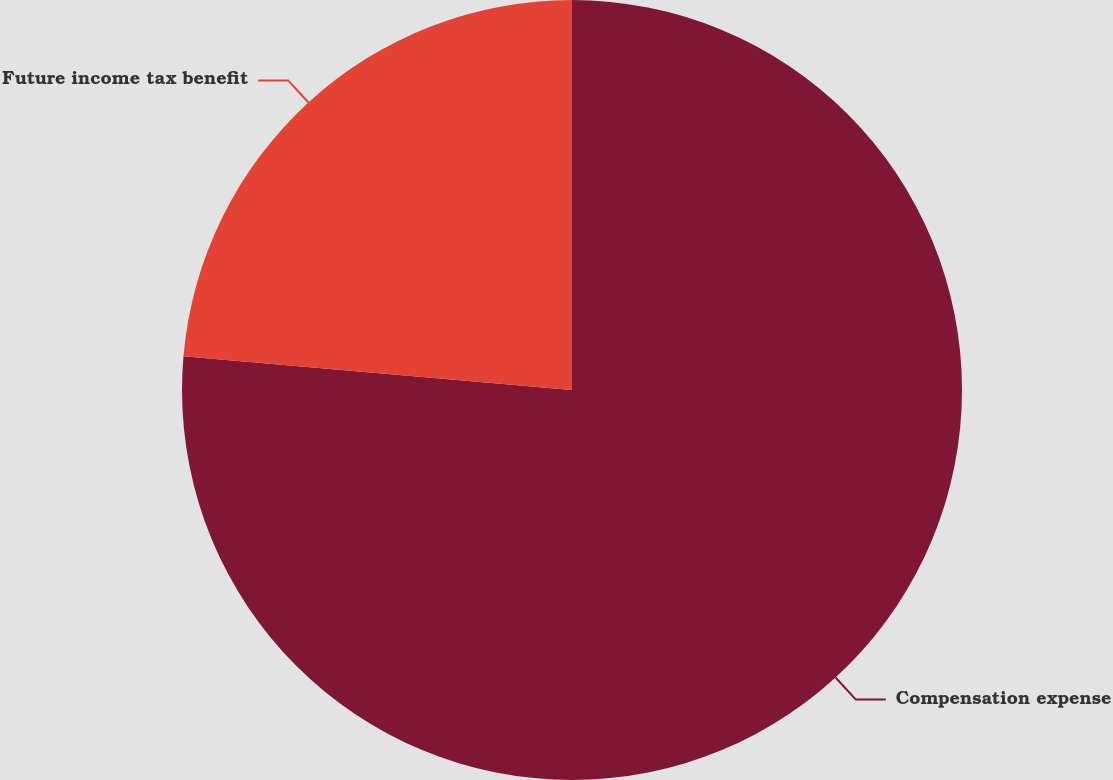<chart> <loc_0><loc_0><loc_500><loc_500><pie_chart><fcel>Compensation expense<fcel>Future income tax benefit<nl><fcel>76.38%<fcel>23.62%<nl></chart> 